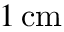Convert formula to latex. <formula><loc_0><loc_0><loc_500><loc_500>1 \, c m</formula> 